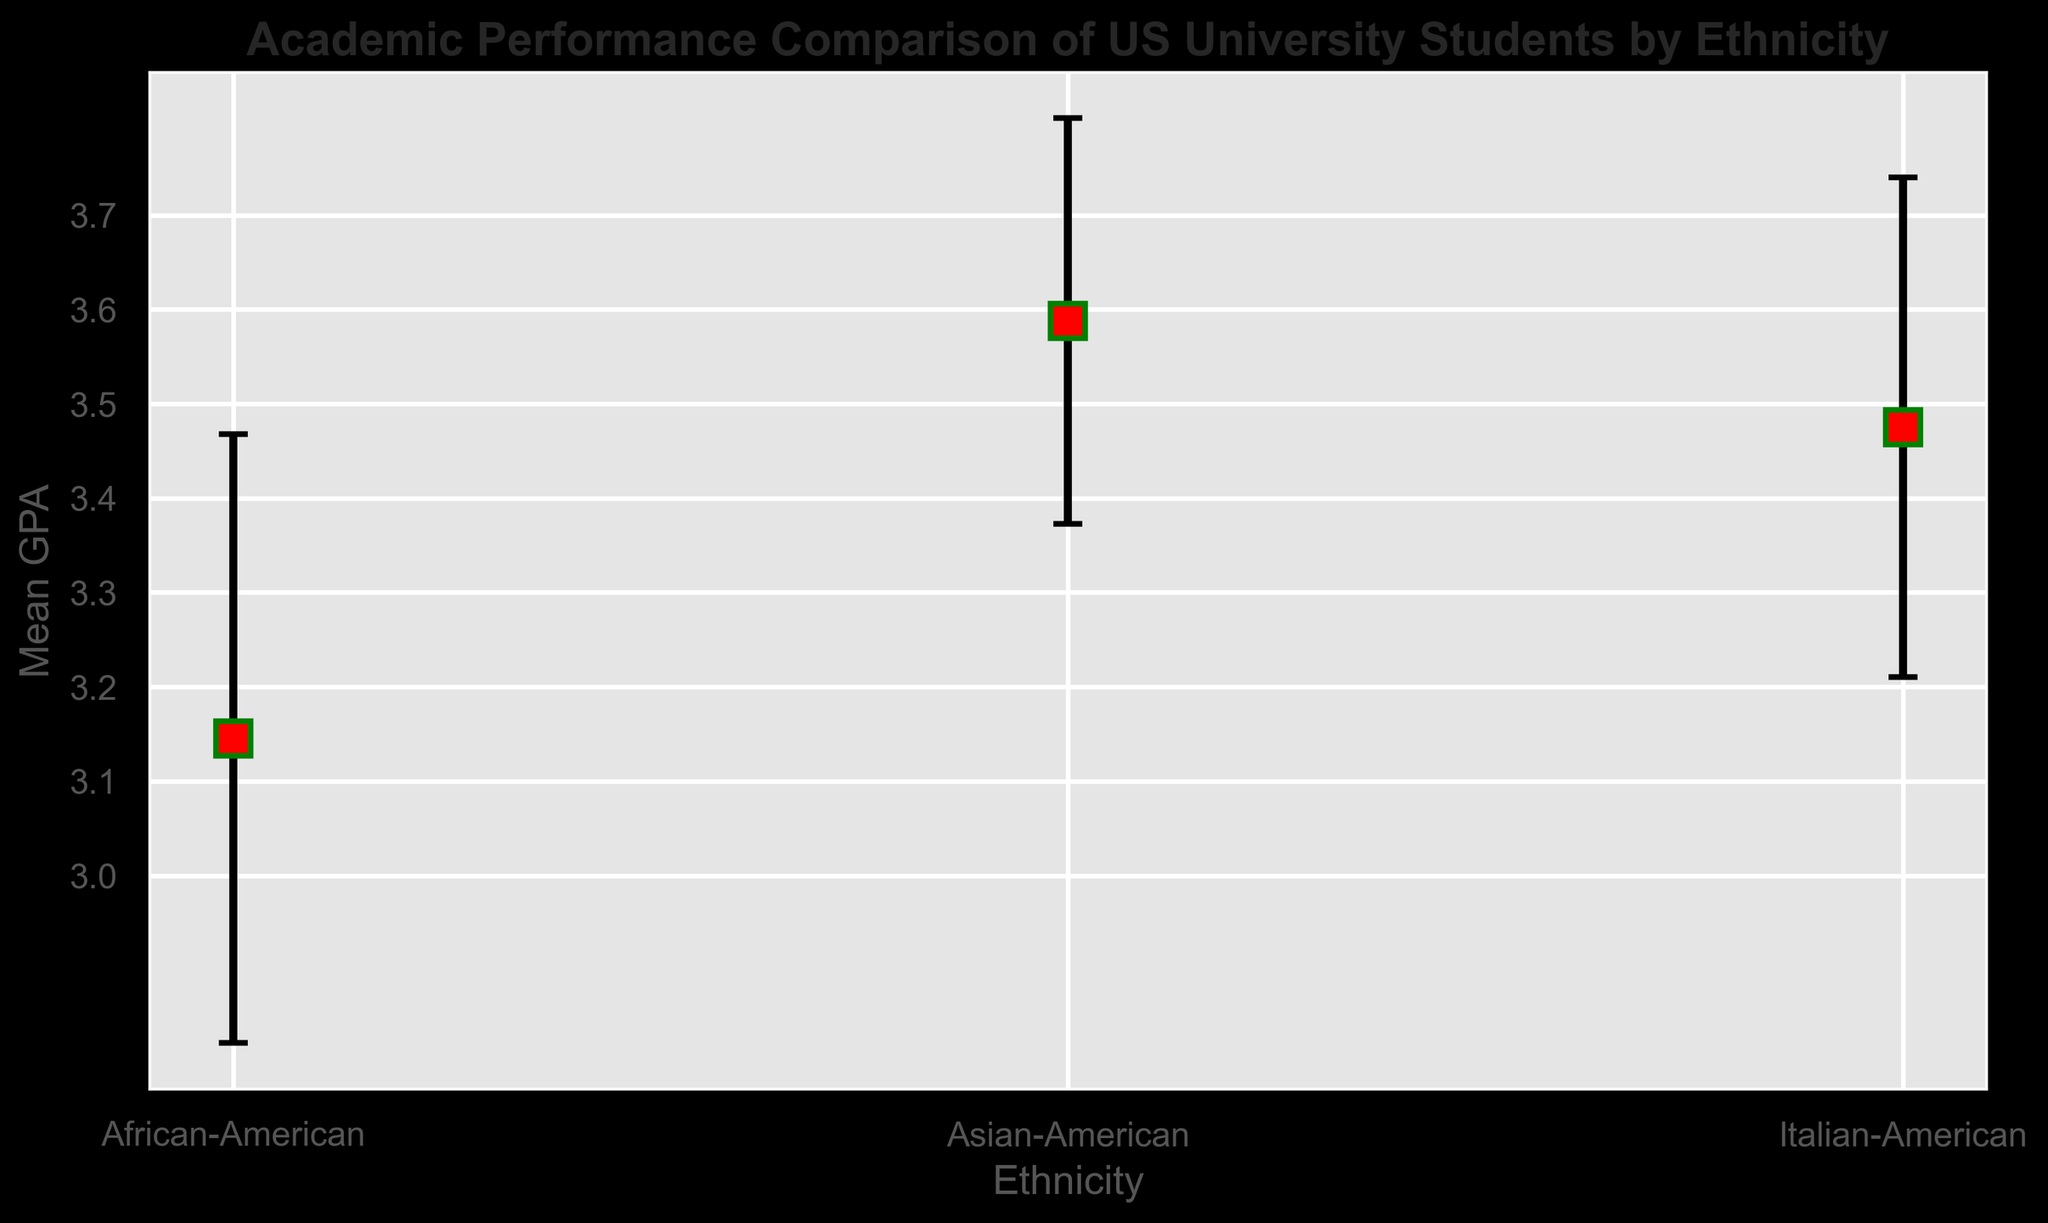What's the average GPA of Italian-American students according to the figure? The figure provides the mean GPA for Italian-American students, which is around 3.475. This is calculated as the mean of the GPAs provided in the data.
Answer: 3.475 Which ethnic group shows the highest average GPA? According to the figure, the Asian-American group shows the highest average GPA with approximately 3.587.
Answer: Asian-American What's the difference between the average GPA of Italian-American and African-American students? The average GPA of Italian-American students is around 3.475 and for African-American students, it is around 3.145. Thus, the difference is 3.475 - 3.145 = 0.33.
Answer: 0.33 Which ethnic group has the largest standard deviation in GPA? The figure shows the error bars representing standard deviations. The African-American group has the largest standard deviation at 0.322.
Answer: African-American How much higher is the average GPA of Asian-American students compared to the overall average GPA of all students? Calculate the overall average GPA for all students: mean of (3.475, 3.145, 3.587) = (3.475 + 3.145 + 3.587) / 3 ≈ 3.402. The average GPA for Asian-American students is 3.587, so the difference is 3.587 - 3.402 ≈ 0.185.
Answer: 0.185 Which group has the smallest error bars, indicating the least variability in GPAs? Based on the figure, the Asian-American group has the smallest error bars (standard deviation of 0.215), indicating the least variability in GPAs.
Answer: Asian-American If a student's GPA is one standard deviation above the mean for Italian-American students, what is their GPA? The mean GPA for Italian-American students is around 3.475, and the standard deviation is 0.265. Thus, a GPA one standard deviation above the mean is 3.475 + 0.265 = 3.74.
Answer: 3.74 What's the range of GPAs one can expect (mean ± standard deviation) for African-American students? The mean GPA for African-American students is around 3.145 and the standard deviation is 0.322. Therefore, the range is approximately 3.145 ± 0.322, which means from 2.823 to 3.467.
Answer: 2.823 to 3.467 Among the three ethnic groups, which one has an average GPA that is closest to 3.5? The average GPA for Italian-American students is 3.475, for African-American it is 3.145, and for Asian-American it is 3.587. The GPA closest to 3.5 is that of the Italian-American students (3.475).
Answer: Italian-American 